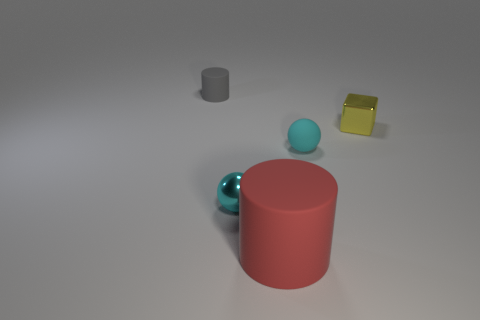Subtract 1 blocks. How many blocks are left? 0 Add 2 small brown shiny blocks. How many objects exist? 7 Subtract all cubes. How many objects are left? 4 Subtract all green blocks. How many red cylinders are left? 1 Subtract all small metal things. Subtract all small blue rubber things. How many objects are left? 3 Add 4 small cyan shiny things. How many small cyan shiny things are left? 5 Add 1 green metallic blocks. How many green metallic blocks exist? 1 Subtract all gray cylinders. How many cylinders are left? 1 Subtract 1 red cylinders. How many objects are left? 4 Subtract all red cubes. Subtract all green balls. How many cubes are left? 1 